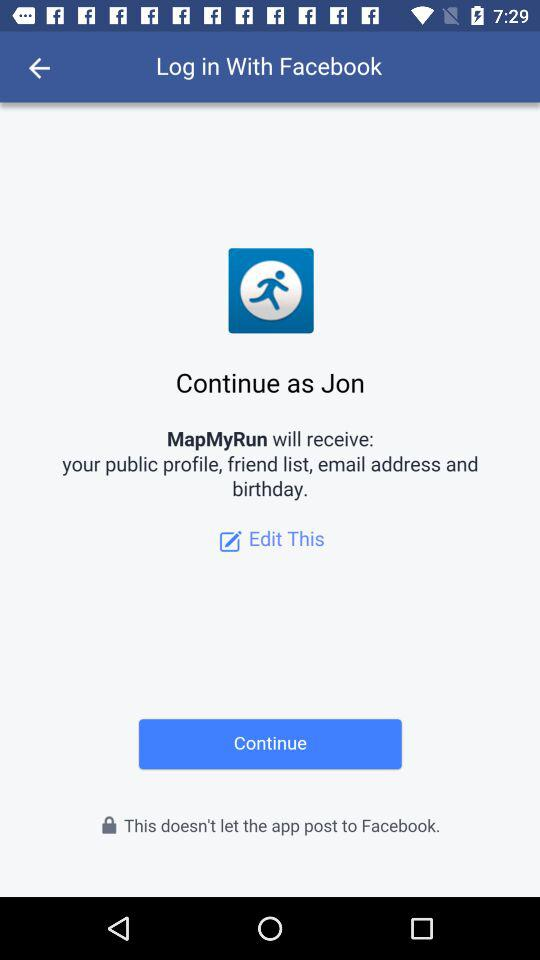What application can be used to log in? The application is "Facebook". 